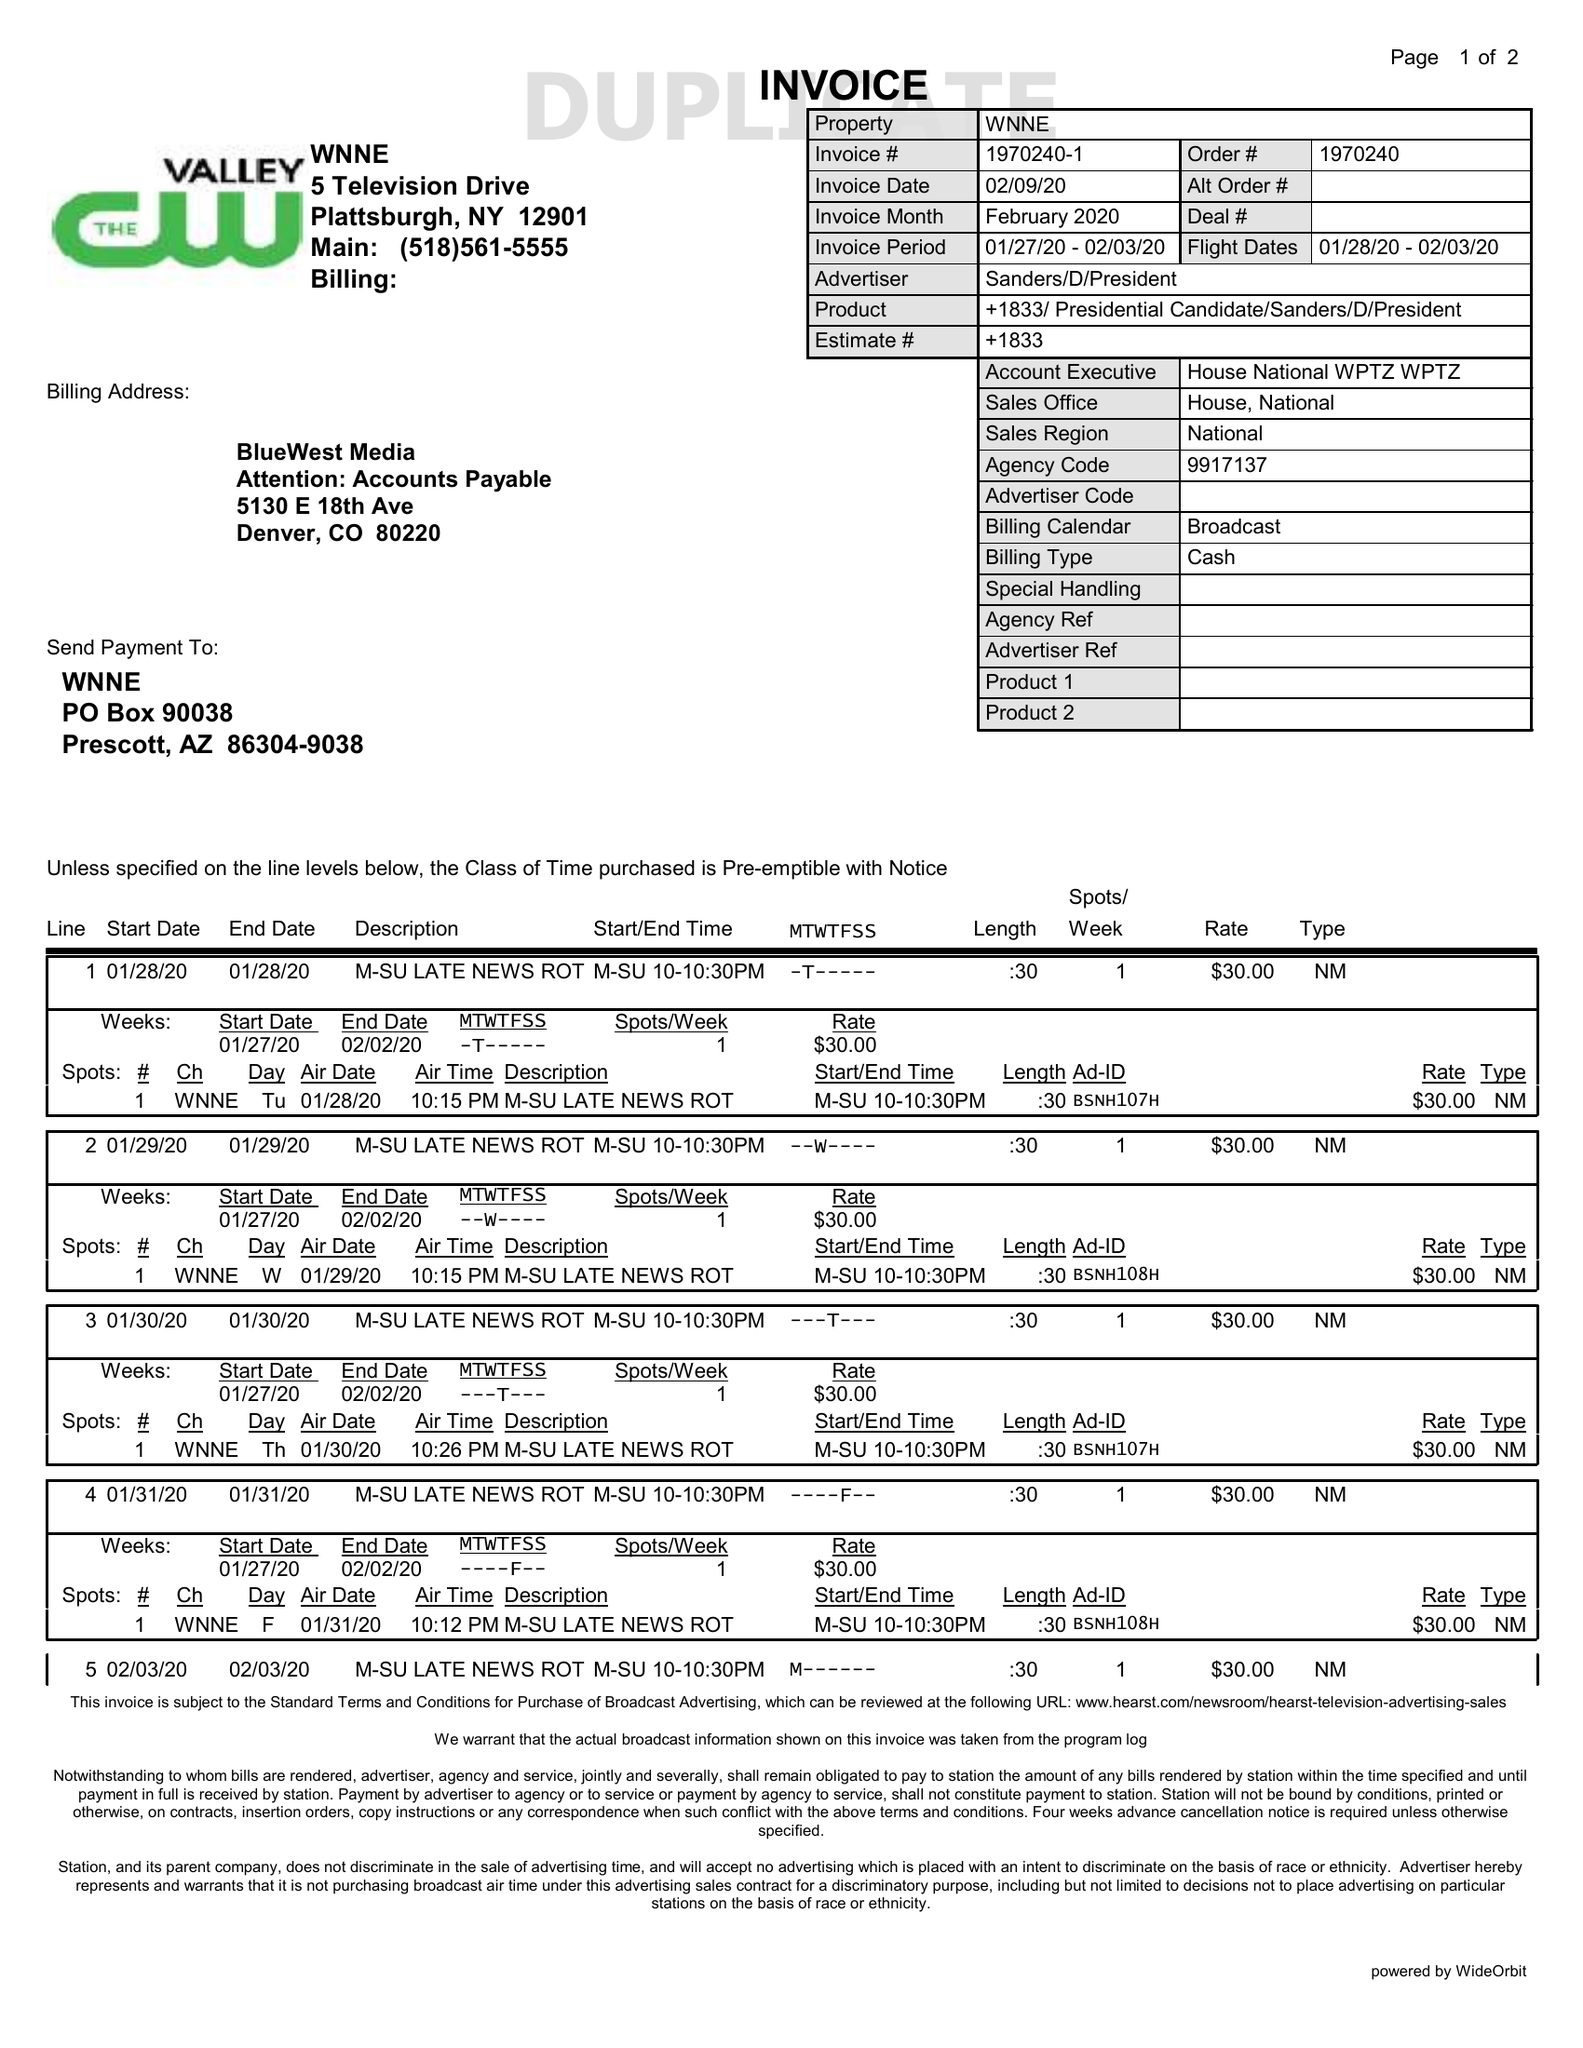What is the value for the contract_num?
Answer the question using a single word or phrase. 1970240 